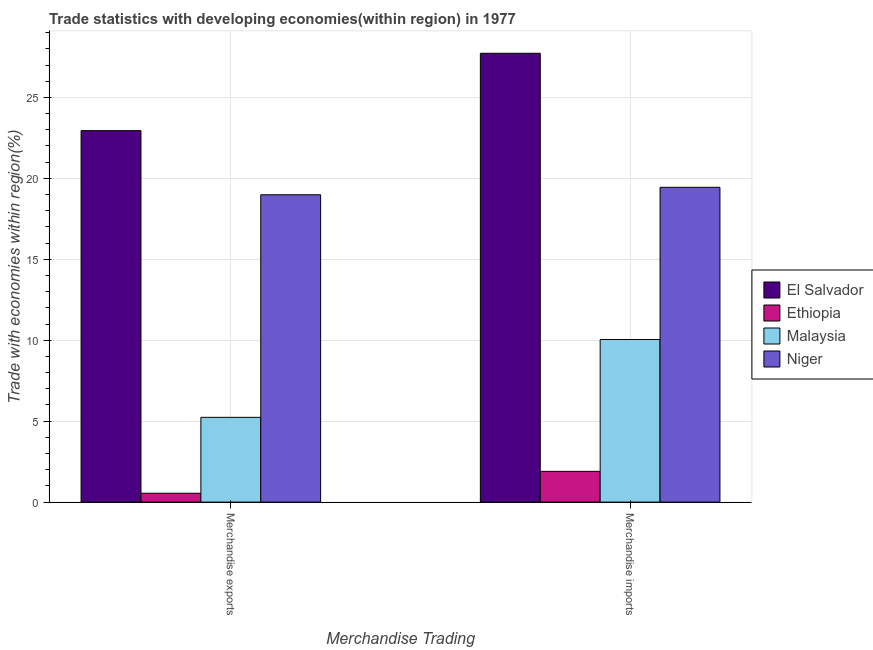How many groups of bars are there?
Make the answer very short. 2. How many bars are there on the 2nd tick from the right?
Offer a terse response. 4. What is the label of the 2nd group of bars from the left?
Offer a very short reply. Merchandise imports. What is the merchandise imports in Ethiopia?
Provide a short and direct response. 1.9. Across all countries, what is the maximum merchandise exports?
Offer a very short reply. 22.95. Across all countries, what is the minimum merchandise exports?
Your response must be concise. 0.55. In which country was the merchandise exports maximum?
Your answer should be very brief. El Salvador. In which country was the merchandise exports minimum?
Your answer should be compact. Ethiopia. What is the total merchandise imports in the graph?
Make the answer very short. 59.12. What is the difference between the merchandise imports in Ethiopia and that in El Salvador?
Provide a succinct answer. -25.83. What is the difference between the merchandise exports in Niger and the merchandise imports in Ethiopia?
Your response must be concise. 17.08. What is the average merchandise imports per country?
Offer a very short reply. 14.78. What is the difference between the merchandise exports and merchandise imports in Niger?
Give a very brief answer. -0.46. What is the ratio of the merchandise imports in Niger to that in El Salvador?
Offer a terse response. 0.7. In how many countries, is the merchandise imports greater than the average merchandise imports taken over all countries?
Your response must be concise. 2. What does the 4th bar from the left in Merchandise exports represents?
Your answer should be very brief. Niger. What does the 4th bar from the right in Merchandise exports represents?
Your answer should be compact. El Salvador. Are all the bars in the graph horizontal?
Make the answer very short. No. How many countries are there in the graph?
Your answer should be compact. 4. What is the difference between two consecutive major ticks on the Y-axis?
Offer a very short reply. 5. Does the graph contain any zero values?
Give a very brief answer. No. Does the graph contain grids?
Provide a short and direct response. Yes. Where does the legend appear in the graph?
Keep it short and to the point. Center right. What is the title of the graph?
Give a very brief answer. Trade statistics with developing economies(within region) in 1977. What is the label or title of the X-axis?
Your answer should be very brief. Merchandise Trading. What is the label or title of the Y-axis?
Provide a succinct answer. Trade with economies within region(%). What is the Trade with economies within region(%) in El Salvador in Merchandise exports?
Keep it short and to the point. 22.95. What is the Trade with economies within region(%) of Ethiopia in Merchandise exports?
Your answer should be compact. 0.55. What is the Trade with economies within region(%) in Malaysia in Merchandise exports?
Your answer should be compact. 5.24. What is the Trade with economies within region(%) of Niger in Merchandise exports?
Ensure brevity in your answer.  18.99. What is the Trade with economies within region(%) of El Salvador in Merchandise imports?
Offer a terse response. 27.73. What is the Trade with economies within region(%) in Ethiopia in Merchandise imports?
Your answer should be very brief. 1.9. What is the Trade with economies within region(%) in Malaysia in Merchandise imports?
Give a very brief answer. 10.05. What is the Trade with economies within region(%) in Niger in Merchandise imports?
Keep it short and to the point. 19.45. Across all Merchandise Trading, what is the maximum Trade with economies within region(%) of El Salvador?
Offer a very short reply. 27.73. Across all Merchandise Trading, what is the maximum Trade with economies within region(%) in Ethiopia?
Provide a succinct answer. 1.9. Across all Merchandise Trading, what is the maximum Trade with economies within region(%) of Malaysia?
Provide a succinct answer. 10.05. Across all Merchandise Trading, what is the maximum Trade with economies within region(%) of Niger?
Your response must be concise. 19.45. Across all Merchandise Trading, what is the minimum Trade with economies within region(%) in El Salvador?
Your answer should be compact. 22.95. Across all Merchandise Trading, what is the minimum Trade with economies within region(%) in Ethiopia?
Provide a short and direct response. 0.55. Across all Merchandise Trading, what is the minimum Trade with economies within region(%) of Malaysia?
Offer a terse response. 5.24. Across all Merchandise Trading, what is the minimum Trade with economies within region(%) in Niger?
Your answer should be compact. 18.99. What is the total Trade with economies within region(%) of El Salvador in the graph?
Provide a succinct answer. 50.68. What is the total Trade with economies within region(%) in Ethiopia in the graph?
Your answer should be very brief. 2.45. What is the total Trade with economies within region(%) in Malaysia in the graph?
Your response must be concise. 15.28. What is the total Trade with economies within region(%) of Niger in the graph?
Offer a very short reply. 38.43. What is the difference between the Trade with economies within region(%) of El Salvador in Merchandise exports and that in Merchandise imports?
Keep it short and to the point. -4.78. What is the difference between the Trade with economies within region(%) of Ethiopia in Merchandise exports and that in Merchandise imports?
Offer a terse response. -1.35. What is the difference between the Trade with economies within region(%) of Malaysia in Merchandise exports and that in Merchandise imports?
Ensure brevity in your answer.  -4.81. What is the difference between the Trade with economies within region(%) in Niger in Merchandise exports and that in Merchandise imports?
Offer a terse response. -0.46. What is the difference between the Trade with economies within region(%) of El Salvador in Merchandise exports and the Trade with economies within region(%) of Ethiopia in Merchandise imports?
Your answer should be very brief. 21.05. What is the difference between the Trade with economies within region(%) of El Salvador in Merchandise exports and the Trade with economies within region(%) of Malaysia in Merchandise imports?
Your answer should be very brief. 12.9. What is the difference between the Trade with economies within region(%) of El Salvador in Merchandise exports and the Trade with economies within region(%) of Niger in Merchandise imports?
Provide a succinct answer. 3.5. What is the difference between the Trade with economies within region(%) in Ethiopia in Merchandise exports and the Trade with economies within region(%) in Malaysia in Merchandise imports?
Keep it short and to the point. -9.5. What is the difference between the Trade with economies within region(%) in Ethiopia in Merchandise exports and the Trade with economies within region(%) in Niger in Merchandise imports?
Offer a terse response. -18.9. What is the difference between the Trade with economies within region(%) of Malaysia in Merchandise exports and the Trade with economies within region(%) of Niger in Merchandise imports?
Your answer should be very brief. -14.21. What is the average Trade with economies within region(%) of El Salvador per Merchandise Trading?
Make the answer very short. 25.34. What is the average Trade with economies within region(%) of Ethiopia per Merchandise Trading?
Your answer should be very brief. 1.22. What is the average Trade with economies within region(%) in Malaysia per Merchandise Trading?
Provide a succinct answer. 7.64. What is the average Trade with economies within region(%) in Niger per Merchandise Trading?
Your response must be concise. 19.22. What is the difference between the Trade with economies within region(%) in El Salvador and Trade with economies within region(%) in Ethiopia in Merchandise exports?
Give a very brief answer. 22.4. What is the difference between the Trade with economies within region(%) in El Salvador and Trade with economies within region(%) in Malaysia in Merchandise exports?
Your response must be concise. 17.71. What is the difference between the Trade with economies within region(%) in El Salvador and Trade with economies within region(%) in Niger in Merchandise exports?
Your answer should be very brief. 3.96. What is the difference between the Trade with economies within region(%) in Ethiopia and Trade with economies within region(%) in Malaysia in Merchandise exports?
Offer a very short reply. -4.69. What is the difference between the Trade with economies within region(%) in Ethiopia and Trade with economies within region(%) in Niger in Merchandise exports?
Keep it short and to the point. -18.44. What is the difference between the Trade with economies within region(%) of Malaysia and Trade with economies within region(%) of Niger in Merchandise exports?
Ensure brevity in your answer.  -13.75. What is the difference between the Trade with economies within region(%) of El Salvador and Trade with economies within region(%) of Ethiopia in Merchandise imports?
Your answer should be very brief. 25.83. What is the difference between the Trade with economies within region(%) in El Salvador and Trade with economies within region(%) in Malaysia in Merchandise imports?
Provide a short and direct response. 17.68. What is the difference between the Trade with economies within region(%) of El Salvador and Trade with economies within region(%) of Niger in Merchandise imports?
Give a very brief answer. 8.28. What is the difference between the Trade with economies within region(%) of Ethiopia and Trade with economies within region(%) of Malaysia in Merchandise imports?
Ensure brevity in your answer.  -8.15. What is the difference between the Trade with economies within region(%) of Ethiopia and Trade with economies within region(%) of Niger in Merchandise imports?
Give a very brief answer. -17.55. What is the difference between the Trade with economies within region(%) in Malaysia and Trade with economies within region(%) in Niger in Merchandise imports?
Your response must be concise. -9.4. What is the ratio of the Trade with economies within region(%) in El Salvador in Merchandise exports to that in Merchandise imports?
Make the answer very short. 0.83. What is the ratio of the Trade with economies within region(%) of Ethiopia in Merchandise exports to that in Merchandise imports?
Your response must be concise. 0.29. What is the ratio of the Trade with economies within region(%) in Malaysia in Merchandise exports to that in Merchandise imports?
Provide a succinct answer. 0.52. What is the ratio of the Trade with economies within region(%) of Niger in Merchandise exports to that in Merchandise imports?
Your answer should be compact. 0.98. What is the difference between the highest and the second highest Trade with economies within region(%) of El Salvador?
Your answer should be very brief. 4.78. What is the difference between the highest and the second highest Trade with economies within region(%) of Ethiopia?
Your response must be concise. 1.35. What is the difference between the highest and the second highest Trade with economies within region(%) in Malaysia?
Give a very brief answer. 4.81. What is the difference between the highest and the second highest Trade with economies within region(%) of Niger?
Your answer should be very brief. 0.46. What is the difference between the highest and the lowest Trade with economies within region(%) in El Salvador?
Your response must be concise. 4.78. What is the difference between the highest and the lowest Trade with economies within region(%) of Ethiopia?
Offer a very short reply. 1.35. What is the difference between the highest and the lowest Trade with economies within region(%) in Malaysia?
Keep it short and to the point. 4.81. What is the difference between the highest and the lowest Trade with economies within region(%) of Niger?
Offer a very short reply. 0.46. 